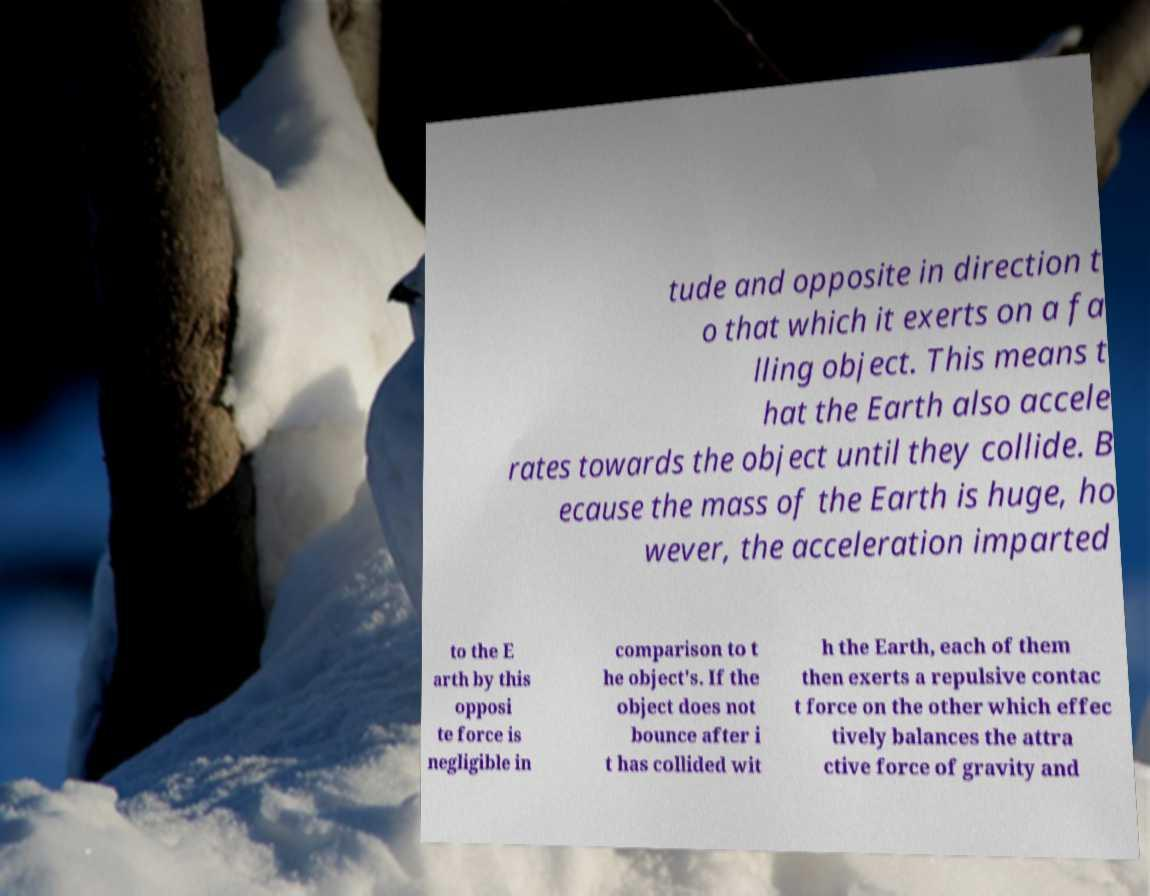Can you accurately transcribe the text from the provided image for me? tude and opposite in direction t o that which it exerts on a fa lling object. This means t hat the Earth also accele rates towards the object until they collide. B ecause the mass of the Earth is huge, ho wever, the acceleration imparted to the E arth by this opposi te force is negligible in comparison to t he object's. If the object does not bounce after i t has collided wit h the Earth, each of them then exerts a repulsive contac t force on the other which effec tively balances the attra ctive force of gravity and 